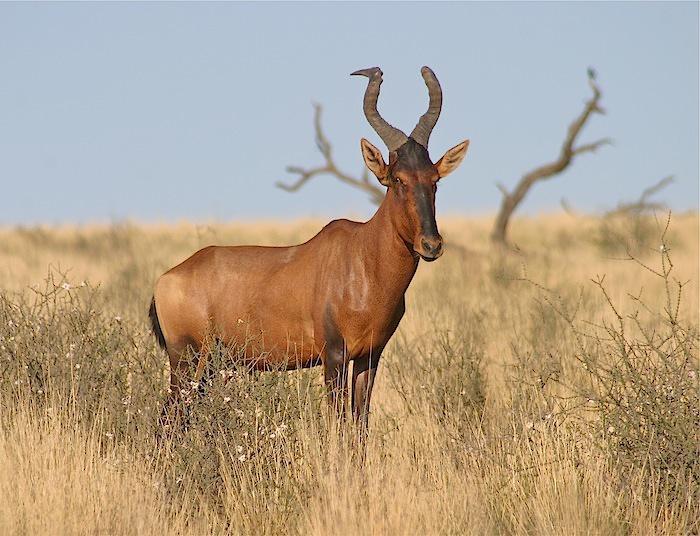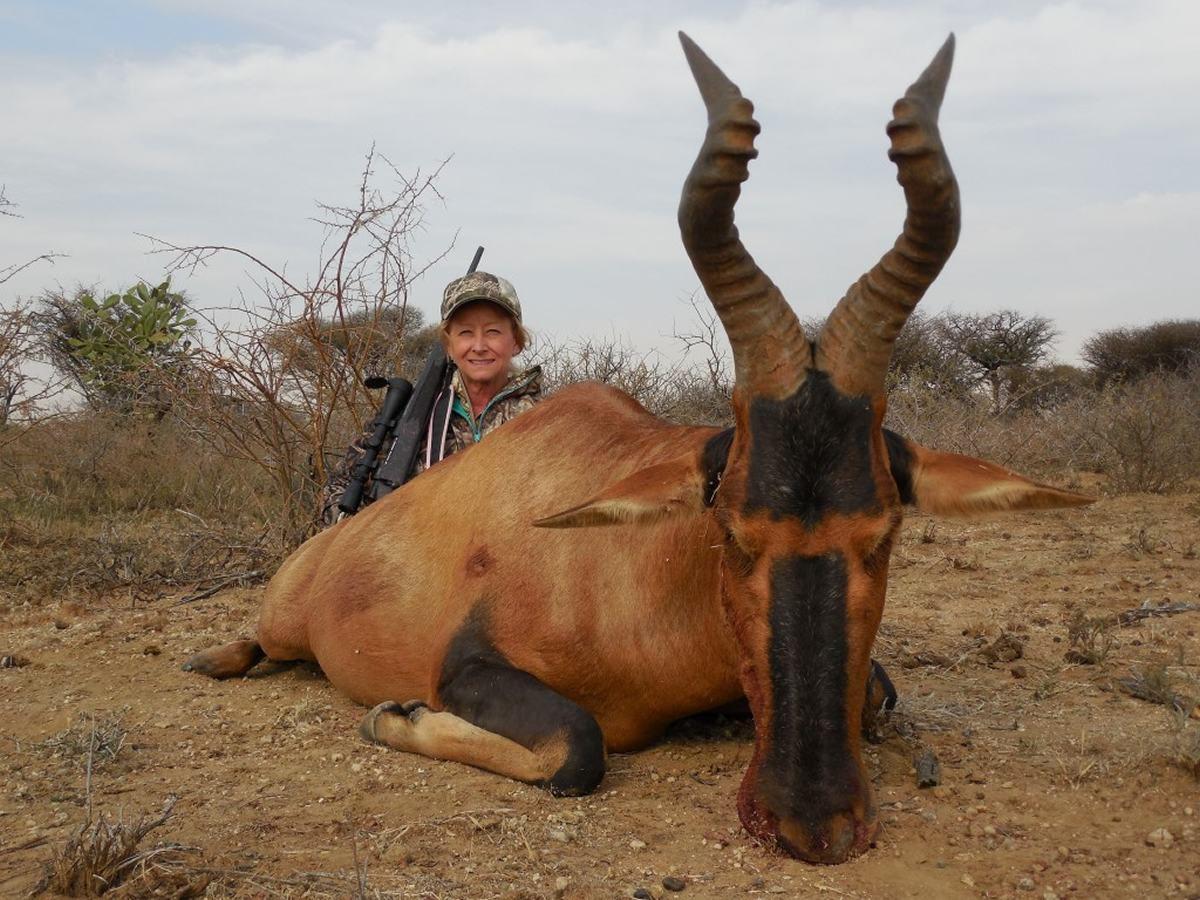The first image is the image on the left, the second image is the image on the right. Evaluate the accuracy of this statement regarding the images: "In one of the images there is a hunter posing behind an animal.". Is it true? Answer yes or no. Yes. 